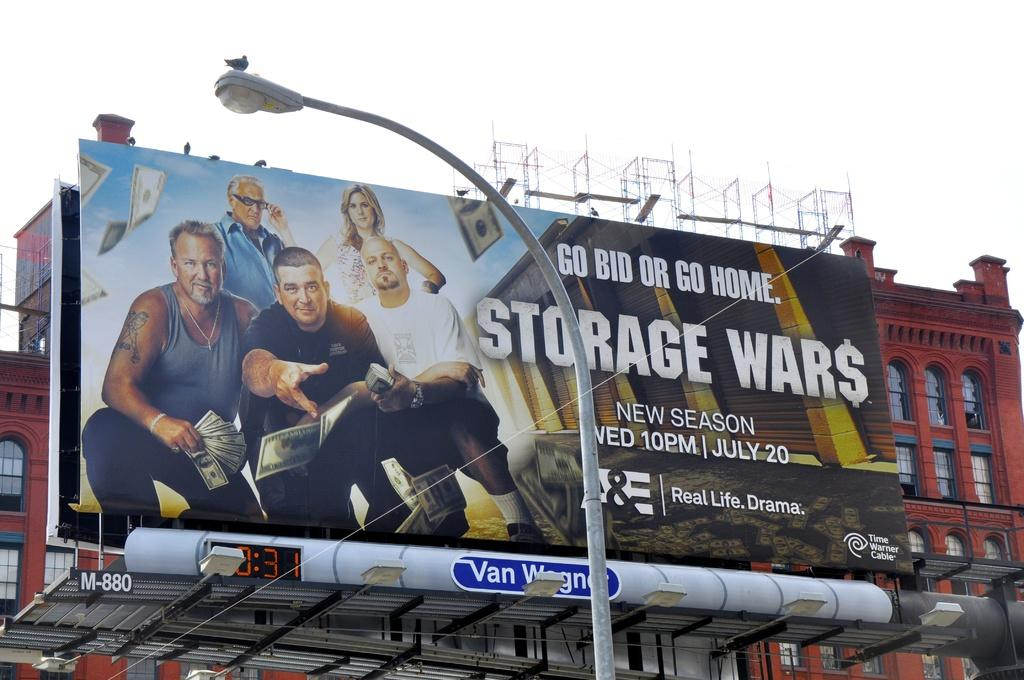<image>
Write a terse but informative summary of the picture. A billboard for the A&E show Storage Wars on a city street. 